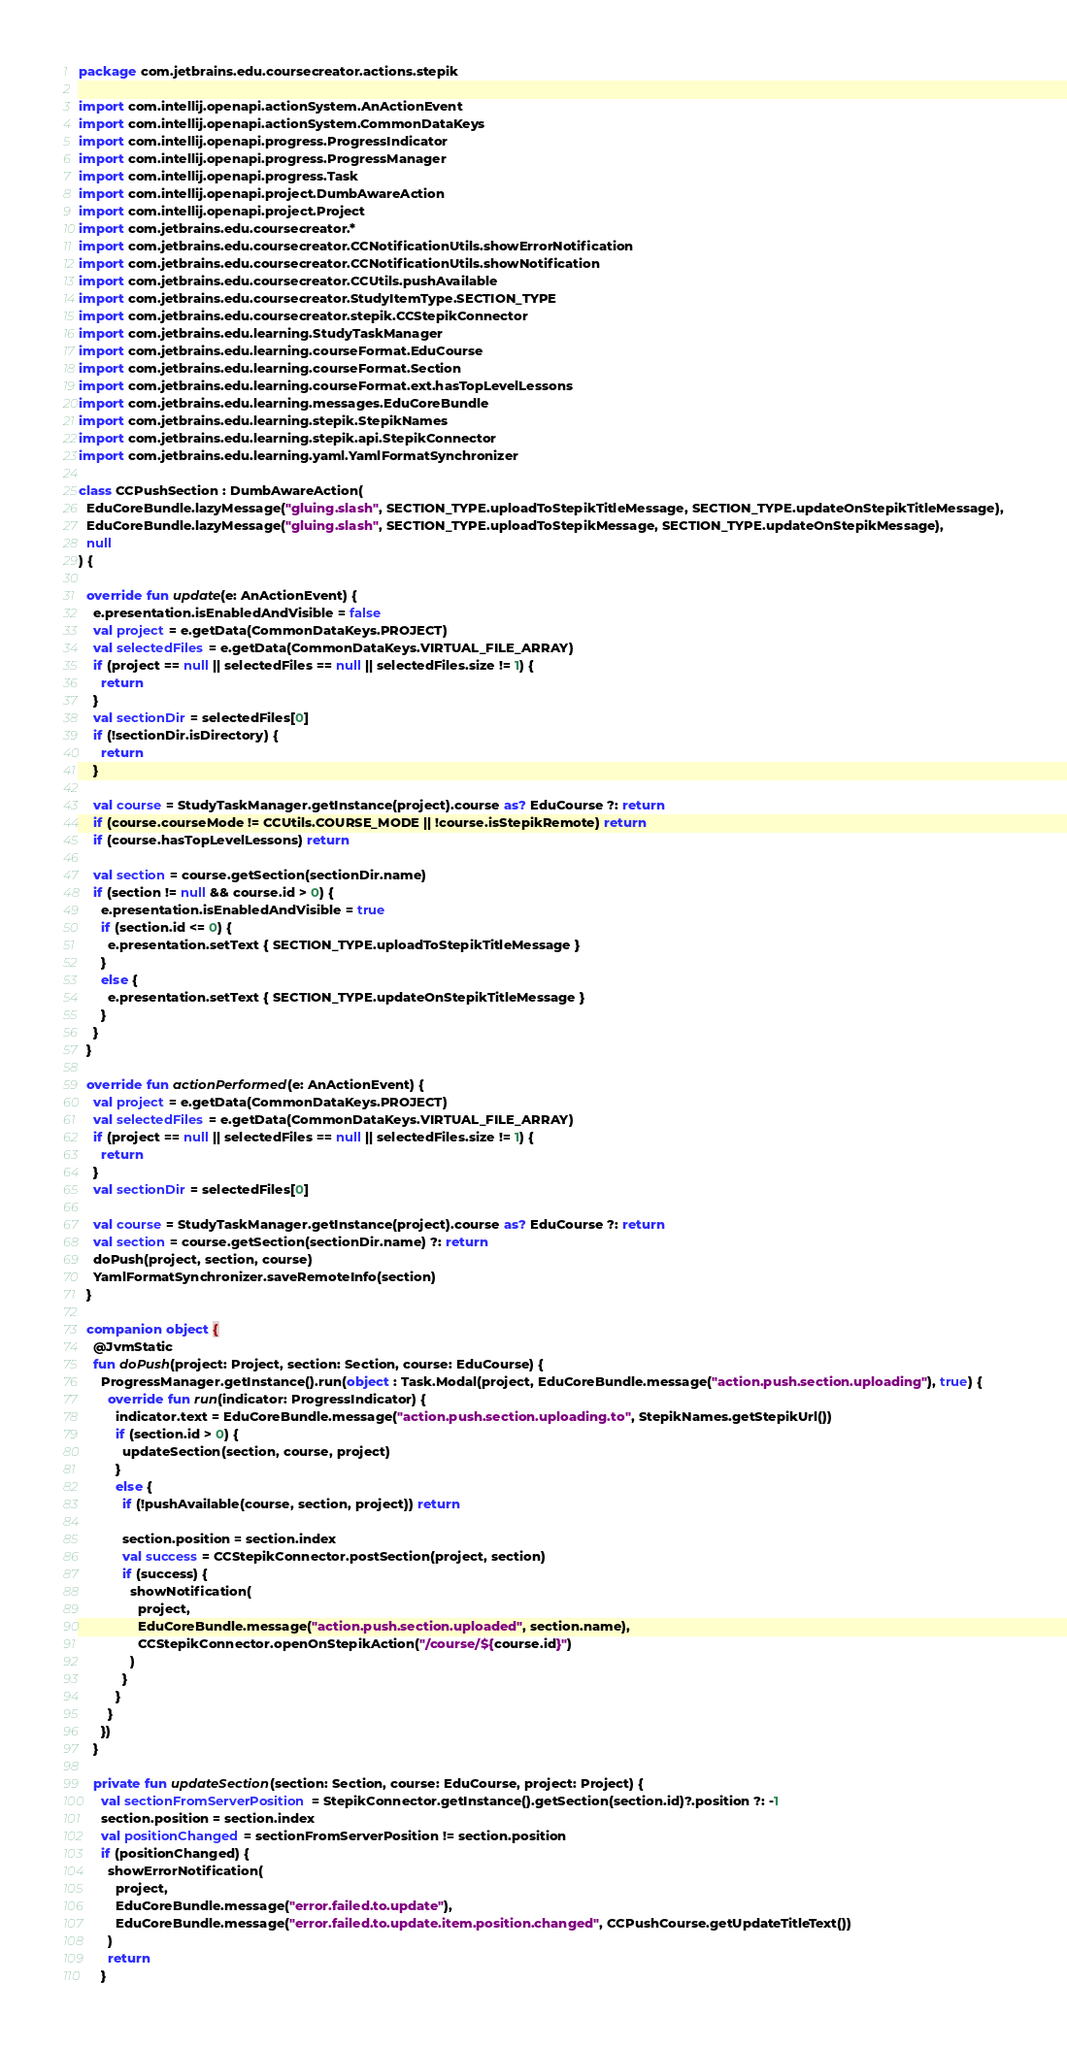<code> <loc_0><loc_0><loc_500><loc_500><_Kotlin_>package com.jetbrains.edu.coursecreator.actions.stepik

import com.intellij.openapi.actionSystem.AnActionEvent
import com.intellij.openapi.actionSystem.CommonDataKeys
import com.intellij.openapi.progress.ProgressIndicator
import com.intellij.openapi.progress.ProgressManager
import com.intellij.openapi.progress.Task
import com.intellij.openapi.project.DumbAwareAction
import com.intellij.openapi.project.Project
import com.jetbrains.edu.coursecreator.*
import com.jetbrains.edu.coursecreator.CCNotificationUtils.showErrorNotification
import com.jetbrains.edu.coursecreator.CCNotificationUtils.showNotification
import com.jetbrains.edu.coursecreator.CCUtils.pushAvailable
import com.jetbrains.edu.coursecreator.StudyItemType.SECTION_TYPE
import com.jetbrains.edu.coursecreator.stepik.CCStepikConnector
import com.jetbrains.edu.learning.StudyTaskManager
import com.jetbrains.edu.learning.courseFormat.EduCourse
import com.jetbrains.edu.learning.courseFormat.Section
import com.jetbrains.edu.learning.courseFormat.ext.hasTopLevelLessons
import com.jetbrains.edu.learning.messages.EduCoreBundle
import com.jetbrains.edu.learning.stepik.StepikNames
import com.jetbrains.edu.learning.stepik.api.StepikConnector
import com.jetbrains.edu.learning.yaml.YamlFormatSynchronizer

class CCPushSection : DumbAwareAction(
  EduCoreBundle.lazyMessage("gluing.slash", SECTION_TYPE.uploadToStepikTitleMessage, SECTION_TYPE.updateOnStepikTitleMessage),
  EduCoreBundle.lazyMessage("gluing.slash", SECTION_TYPE.uploadToStepikMessage, SECTION_TYPE.updateOnStepikMessage),
  null
) {

  override fun update(e: AnActionEvent) {
    e.presentation.isEnabledAndVisible = false
    val project = e.getData(CommonDataKeys.PROJECT)
    val selectedFiles = e.getData(CommonDataKeys.VIRTUAL_FILE_ARRAY)
    if (project == null || selectedFiles == null || selectedFiles.size != 1) {
      return
    }
    val sectionDir = selectedFiles[0]
    if (!sectionDir.isDirectory) {
      return
    }

    val course = StudyTaskManager.getInstance(project).course as? EduCourse ?: return
    if (course.courseMode != CCUtils.COURSE_MODE || !course.isStepikRemote) return
    if (course.hasTopLevelLessons) return

    val section = course.getSection(sectionDir.name)
    if (section != null && course.id > 0) {
      e.presentation.isEnabledAndVisible = true
      if (section.id <= 0) {
        e.presentation.setText { SECTION_TYPE.uploadToStepikTitleMessage }
      }
      else {
        e.presentation.setText { SECTION_TYPE.updateOnStepikTitleMessage }
      }
    }
  }

  override fun actionPerformed(e: AnActionEvent) {
    val project = e.getData(CommonDataKeys.PROJECT)
    val selectedFiles = e.getData(CommonDataKeys.VIRTUAL_FILE_ARRAY)
    if (project == null || selectedFiles == null || selectedFiles.size != 1) {
      return
    }
    val sectionDir = selectedFiles[0]

    val course = StudyTaskManager.getInstance(project).course as? EduCourse ?: return
    val section = course.getSection(sectionDir.name) ?: return
    doPush(project, section, course)
    YamlFormatSynchronizer.saveRemoteInfo(section)
  }

  companion object {
    @JvmStatic
    fun doPush(project: Project, section: Section, course: EduCourse) {
      ProgressManager.getInstance().run(object : Task.Modal(project, EduCoreBundle.message("action.push.section.uploading"), true) {
        override fun run(indicator: ProgressIndicator) {
          indicator.text = EduCoreBundle.message("action.push.section.uploading.to", StepikNames.getStepikUrl())
          if (section.id > 0) {
            updateSection(section, course, project)
          }
          else {
            if (!pushAvailable(course, section, project)) return

            section.position = section.index
            val success = CCStepikConnector.postSection(project, section)
            if (success) {
              showNotification(
                project,
                EduCoreBundle.message("action.push.section.uploaded", section.name),
                CCStepikConnector.openOnStepikAction("/course/${course.id}")
              )
            }
          }
        }
      })
    }

    private fun updateSection(section: Section, course: EduCourse, project: Project) {
      val sectionFromServerPosition = StepikConnector.getInstance().getSection(section.id)?.position ?: -1
      section.position = section.index
      val positionChanged = sectionFromServerPosition != section.position
      if (positionChanged) {
        showErrorNotification(
          project,
          EduCoreBundle.message("error.failed.to.update"),
          EduCoreBundle.message("error.failed.to.update.item.position.changed", CCPushCourse.getUpdateTitleText())
        )
        return
      }</code> 